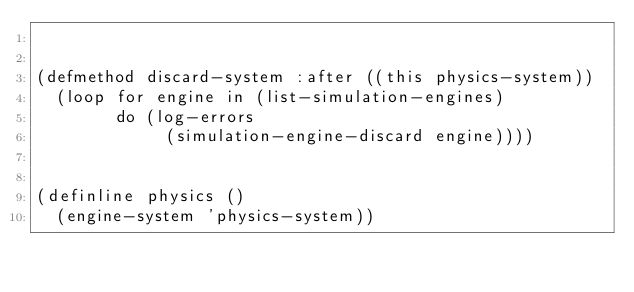Convert code to text. <code><loc_0><loc_0><loc_500><loc_500><_Lisp_>

(defmethod discard-system :after ((this physics-system))
  (loop for engine in (list-simulation-engines)
        do (log-errors
             (simulation-engine-discard engine))))


(definline physics ()
  (engine-system 'physics-system))
</code> 